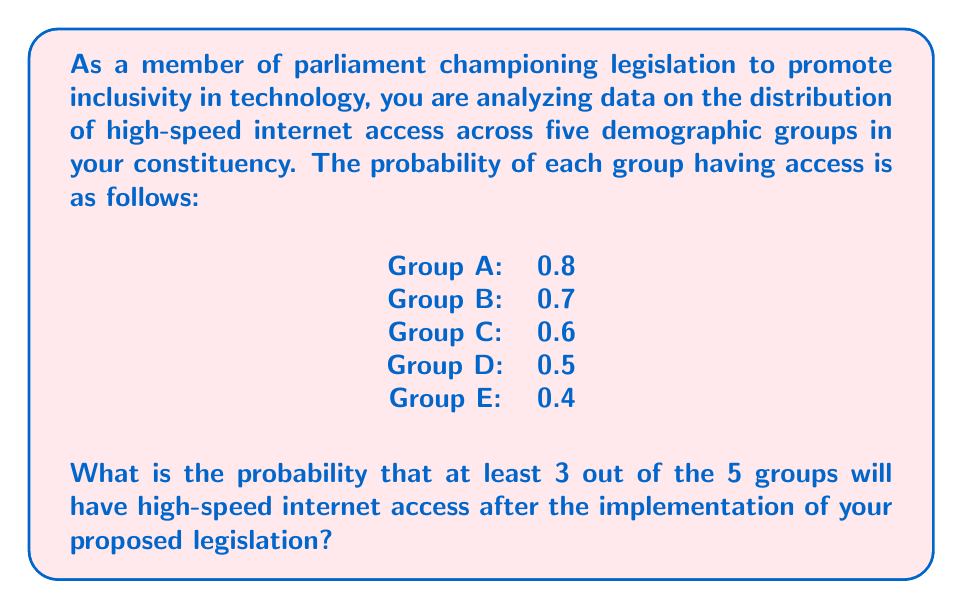Solve this math problem. To solve this problem, we need to use the concept of binomial probability. We can consider each group's access as a Bernoulli trial, where success is having high-speed internet access.

Let's approach this step-by-step:

1) First, we need to calculate the probability of exactly 3, 4, and 5 groups having access, then sum these probabilities.

2) The probability of success for each trial is different, so we need to use the Poisson binomial distribution. However, for simplicity, we can approximate by using the average probability of success:

   $p_{avg} = \frac{0.8 + 0.7 + 0.6 + 0.5 + 0.4}{5} = 0.6$

3) Now we can use the binomial probability formula:

   $P(X = k) = \binom{n}{k} p^k (1-p)^{n-k}$

   Where $n = 5$ (total groups), $k$ is the number of successful groups, and $p = 0.6$

4) Let's calculate for k = 3, 4, and 5:

   $P(X = 3) = \binom{5}{3} (0.6)^3 (0.4)^2 = 10 \cdot 0.216 \cdot 0.16 = 0.3456$

   $P(X = 4) = \binom{5}{4} (0.6)^4 (0.4)^1 = 5 \cdot 0.1296 \cdot 0.4 = 0.2592$

   $P(X = 5) = \binom{5}{5} (0.6)^5 (0.4)^0 = 1 \cdot 0.07776 = 0.07776$

5) The probability of at least 3 groups having access is the sum of these probabilities:

   $P(X \geq 3) = P(X = 3) + P(X = 4) + P(X = 5)$
                $= 0.3456 + 0.2592 + 0.07776$
                $= 0.68256$
Answer: The probability that at least 3 out of the 5 demographic groups will have high-speed internet access is approximately $0.68$ or $68\%$. 